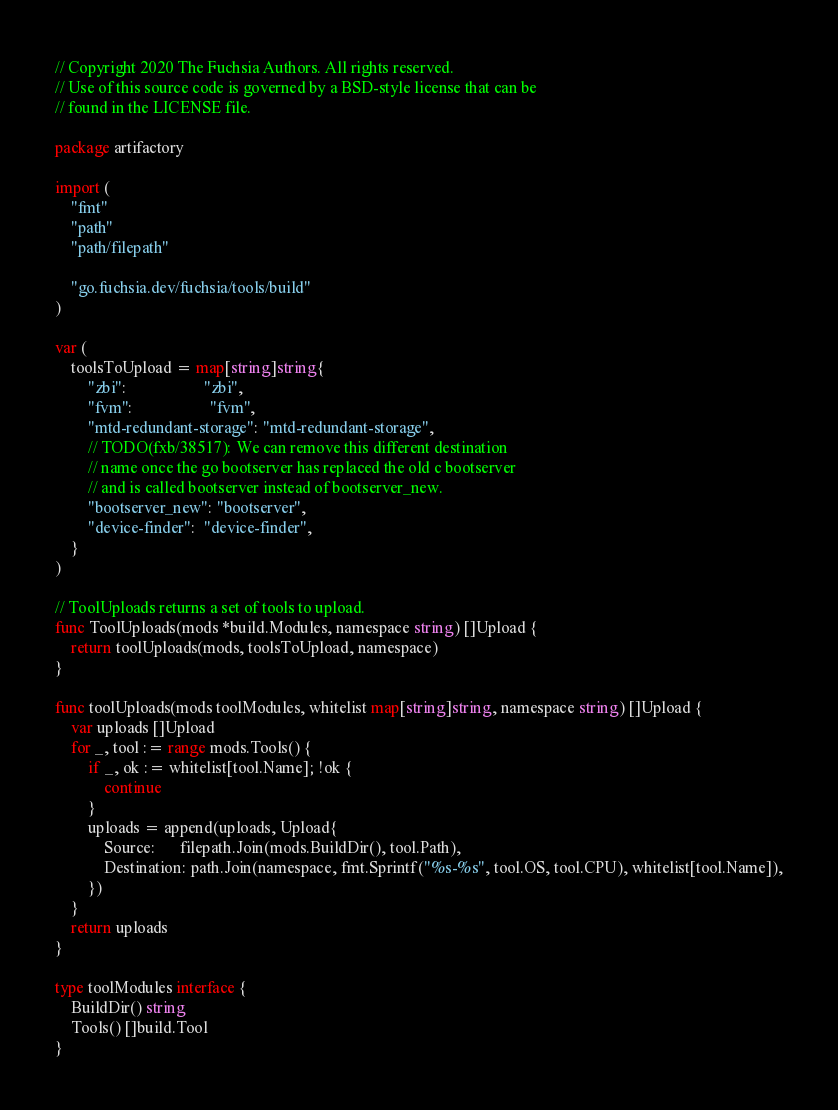Convert code to text. <code><loc_0><loc_0><loc_500><loc_500><_Go_>// Copyright 2020 The Fuchsia Authors. All rights reserved.
// Use of this source code is governed by a BSD-style license that can be
// found in the LICENSE file.

package artifactory

import (
	"fmt"
	"path"
	"path/filepath"

	"go.fuchsia.dev/fuchsia/tools/build"
)

var (
	toolsToUpload = map[string]string{
		"zbi":                   "zbi",
		"fvm":                   "fvm",
		"mtd-redundant-storage": "mtd-redundant-storage",
		// TODO(fxb/38517): We can remove this different destination
		// name once the go bootserver has replaced the old c bootserver
		// and is called bootserver instead of bootserver_new.
		"bootserver_new": "bootserver",
		"device-finder":  "device-finder",
	}
)

// ToolUploads returns a set of tools to upload.
func ToolUploads(mods *build.Modules, namespace string) []Upload {
	return toolUploads(mods, toolsToUpload, namespace)
}

func toolUploads(mods toolModules, whitelist map[string]string, namespace string) []Upload {
	var uploads []Upload
	for _, tool := range mods.Tools() {
		if _, ok := whitelist[tool.Name]; !ok {
			continue
		}
		uploads = append(uploads, Upload{
			Source:      filepath.Join(mods.BuildDir(), tool.Path),
			Destination: path.Join(namespace, fmt.Sprintf("%s-%s", tool.OS, tool.CPU), whitelist[tool.Name]),
		})
	}
	return uploads
}

type toolModules interface {
	BuildDir() string
	Tools() []build.Tool
}
</code> 